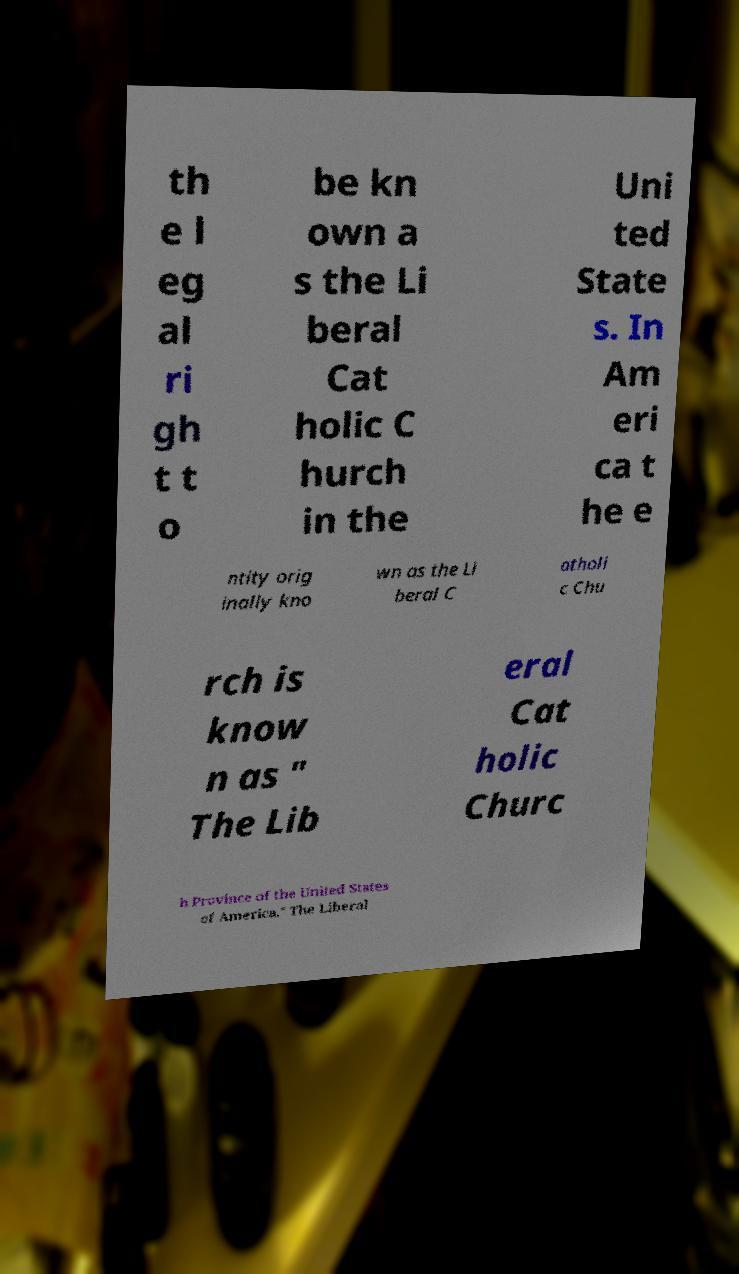Can you read and provide the text displayed in the image?This photo seems to have some interesting text. Can you extract and type it out for me? th e l eg al ri gh t t o be kn own a s the Li beral Cat holic C hurch in the Uni ted State s. In Am eri ca t he e ntity orig inally kno wn as the Li beral C atholi c Chu rch is know n as " The Lib eral Cat holic Churc h Province of the United States of America." The Liberal 